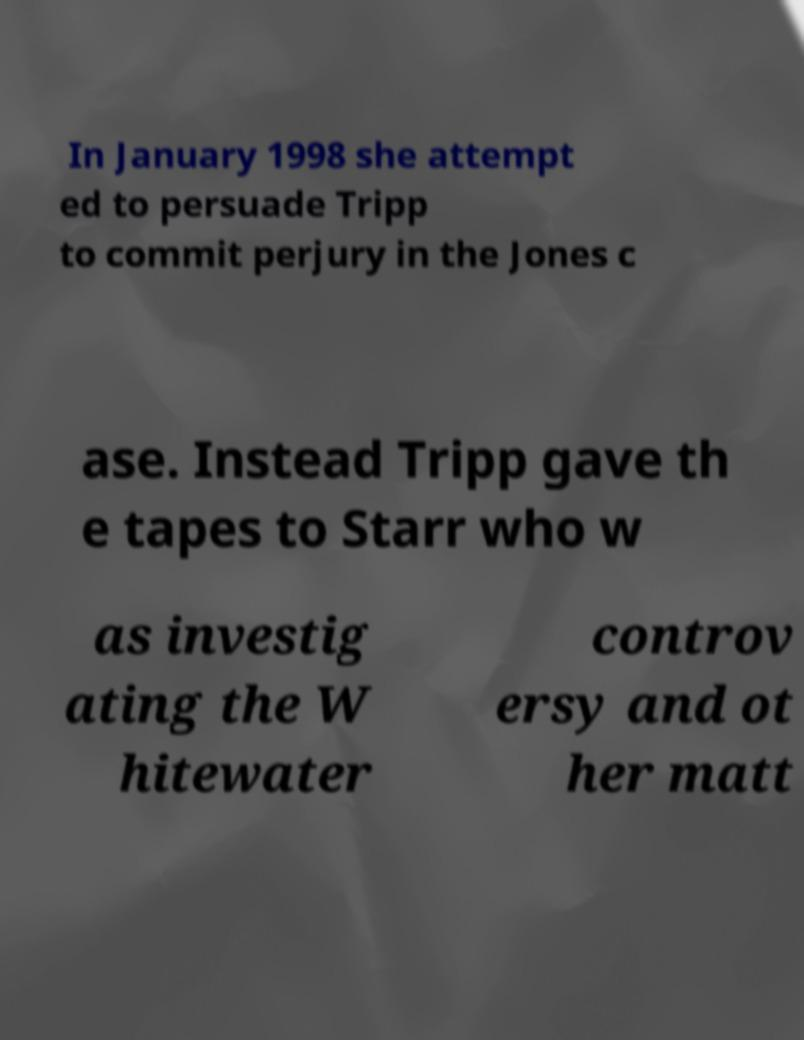Could you extract and type out the text from this image? In January 1998 she attempt ed to persuade Tripp to commit perjury in the Jones c ase. Instead Tripp gave th e tapes to Starr who w as investig ating the W hitewater controv ersy and ot her matt 